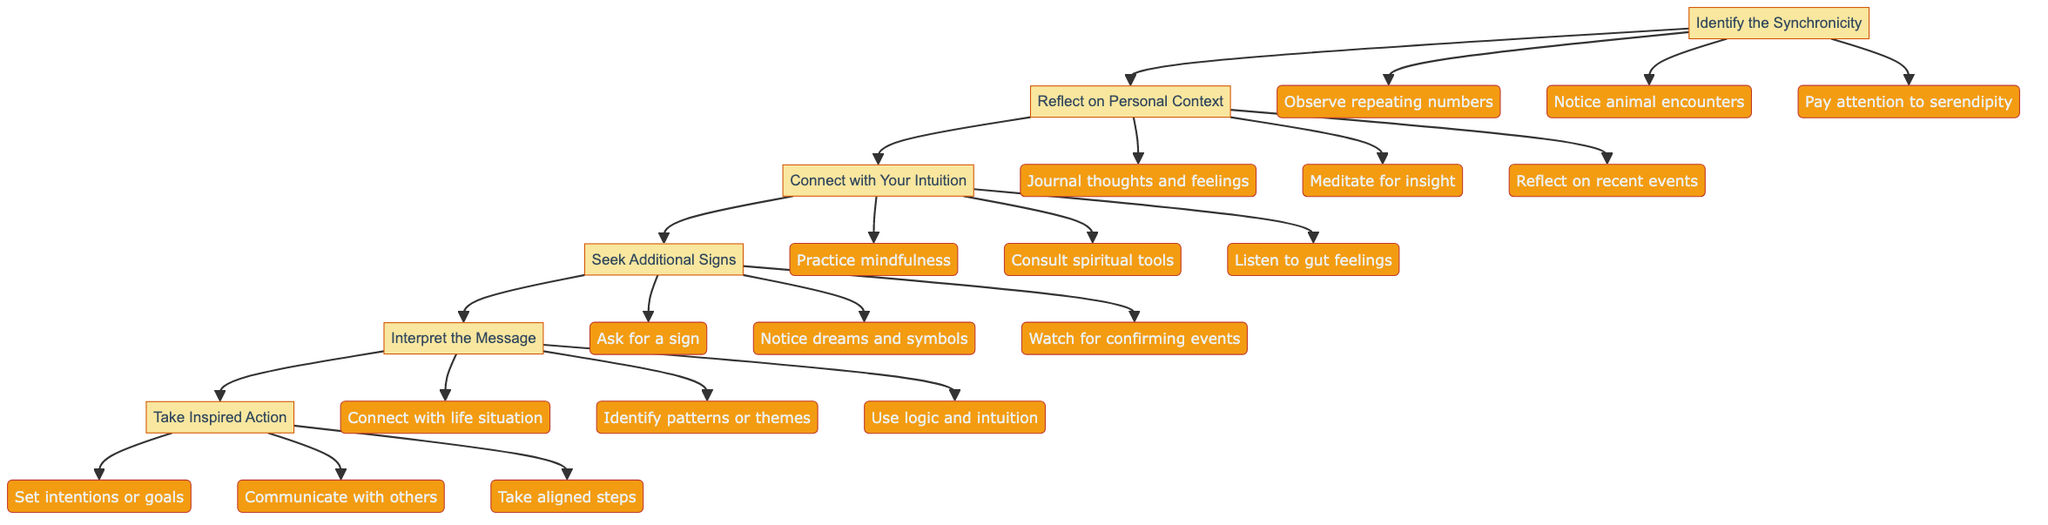What is the first step in the diagram? The diagram starts with "Identify the Synchronicity" as the first step outlined in the flowchart.
Answer: Identify the Synchronicity How many actions are outlined under "Reflect on Personal Context"? There are three actions listed under "Reflect on Personal Context": journal your thoughts and feelings, meditate for insight, and reflect on recent events.
Answer: 3 What follows after "Connect with Your Intuition"? Following "Connect with Your Intuition", the next step in the diagram is "Seek Additional Signs", indicating the flow of actions from one step to the next.
Answer: Seek Additional Signs Which actions can you take to "Seek Additional Signs"? The actions to "Seek Additional Signs" include: ask for a sign, notice dreams and symbols, and watch for confirming events.
Answer: Ask for a sign, notice dreams, watch for confirming events What is the final step of the process? The last step in the flowchart is "Take Inspired Action," which indicates the culmination of the previous steps into actionable outcomes.
Answer: Take Inspired Action Explain how to interpret the message from synchronicities. To interpret the message, you analyze the significance by connecting the synchronicity with your life situation, identifying any patterns or themes, and using both logic and intuition in your reasoning process.
Answer: Analyze significance How many steps are there in total in the diagram? The diagram contains six steps, beginning with identifying synchronicities and culminating in taking inspired action, sequentially leading from one to the next.
Answer: 6 What is the purpose of journaling your thoughts and feelings? Journaling your thoughts and feelings serves to clarify your personal context and may provide insights into the synchronicity by ensuring that you are aware of your mental and emotional state at that time.
Answer: Clarify personal context What types of feelings should you listen to when connecting with your intuition? You should listen to gut feelings and inner voices, as these intuitive signals can guide your understanding of the synchronicity and its meaning in your life.
Answer: Gut feelings, inner voices 